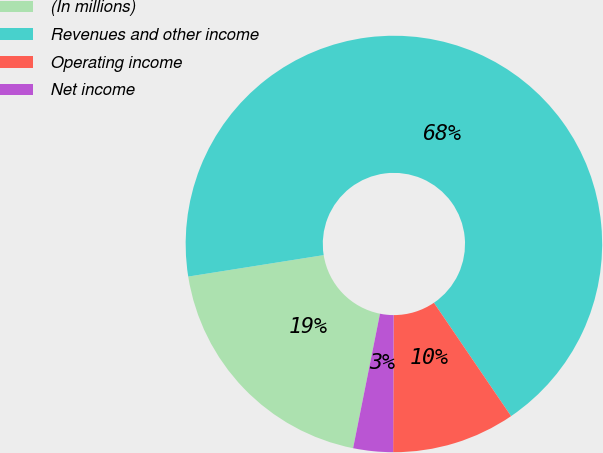Convert chart. <chart><loc_0><loc_0><loc_500><loc_500><pie_chart><fcel>(In millions)<fcel>Revenues and other income<fcel>Operating income<fcel>Net income<nl><fcel>19.36%<fcel>67.99%<fcel>9.57%<fcel>3.08%<nl></chart> 